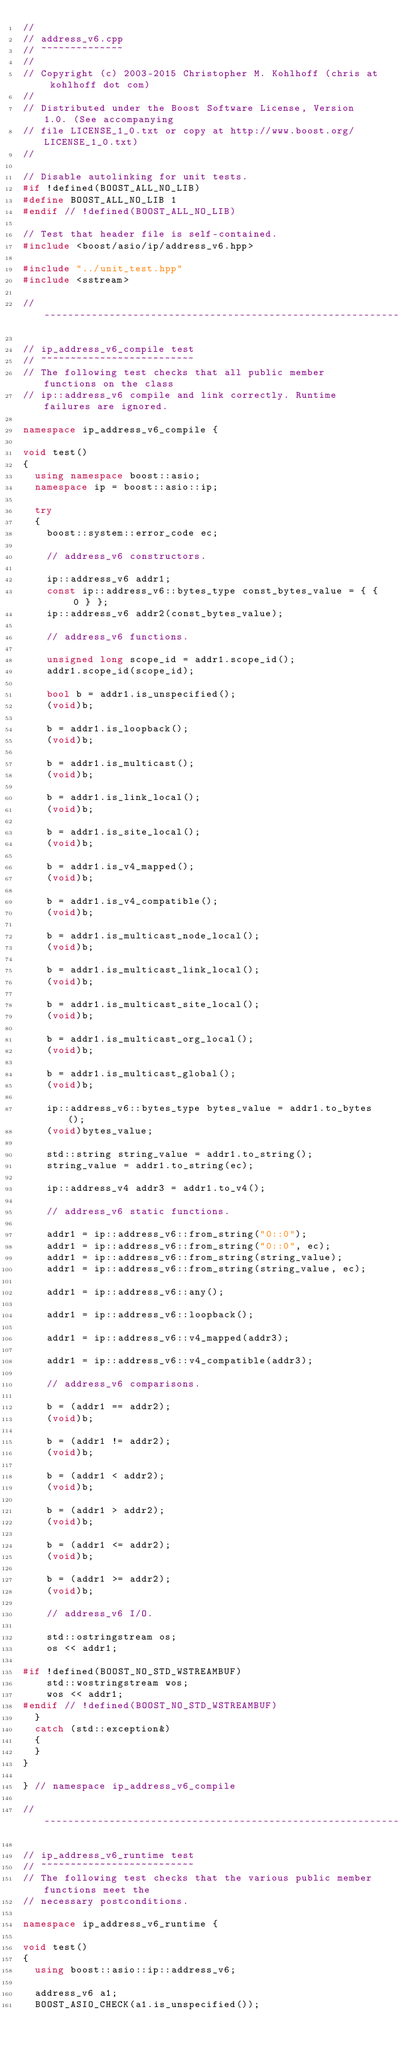Convert code to text. <code><loc_0><loc_0><loc_500><loc_500><_C++_>//
// address_v6.cpp
// ~~~~~~~~~~~~~~
//
// Copyright (c) 2003-2015 Christopher M. Kohlhoff (chris at kohlhoff dot com)
//
// Distributed under the Boost Software License, Version 1.0. (See accompanying
// file LICENSE_1_0.txt or copy at http://www.boost.org/LICENSE_1_0.txt)
//

// Disable autolinking for unit tests.
#if !defined(BOOST_ALL_NO_LIB)
#define BOOST_ALL_NO_LIB 1
#endif // !defined(BOOST_ALL_NO_LIB)

// Test that header file is self-contained.
#include <boost/asio/ip/address_v6.hpp>

#include "../unit_test.hpp"
#include <sstream>

//------------------------------------------------------------------------------

// ip_address_v6_compile test
// ~~~~~~~~~~~~~~~~~~~~~~~~~~
// The following test checks that all public member functions on the class
// ip::address_v6 compile and link correctly. Runtime failures are ignored.

namespace ip_address_v6_compile {

void test()
{
  using namespace boost::asio;
  namespace ip = boost::asio::ip;

  try
  {
    boost::system::error_code ec;

    // address_v6 constructors.

    ip::address_v6 addr1;
    const ip::address_v6::bytes_type const_bytes_value = { { 0 } };
    ip::address_v6 addr2(const_bytes_value);

    // address_v6 functions.

    unsigned long scope_id = addr1.scope_id();
    addr1.scope_id(scope_id);

    bool b = addr1.is_unspecified();
    (void)b;

    b = addr1.is_loopback();
    (void)b;

    b = addr1.is_multicast();
    (void)b;

    b = addr1.is_link_local();
    (void)b;

    b = addr1.is_site_local();
    (void)b;

    b = addr1.is_v4_mapped();
    (void)b;

    b = addr1.is_v4_compatible();
    (void)b;

    b = addr1.is_multicast_node_local();
    (void)b;

    b = addr1.is_multicast_link_local();
    (void)b;

    b = addr1.is_multicast_site_local();
    (void)b;

    b = addr1.is_multicast_org_local();
    (void)b;

    b = addr1.is_multicast_global();
    (void)b;

    ip::address_v6::bytes_type bytes_value = addr1.to_bytes();
    (void)bytes_value;

    std::string string_value = addr1.to_string();
    string_value = addr1.to_string(ec);

    ip::address_v4 addr3 = addr1.to_v4();

    // address_v6 static functions.

    addr1 = ip::address_v6::from_string("0::0");
    addr1 = ip::address_v6::from_string("0::0", ec);
    addr1 = ip::address_v6::from_string(string_value);
    addr1 = ip::address_v6::from_string(string_value, ec);

    addr1 = ip::address_v6::any();

    addr1 = ip::address_v6::loopback();

    addr1 = ip::address_v6::v4_mapped(addr3);

    addr1 = ip::address_v6::v4_compatible(addr3);

    // address_v6 comparisons.

    b = (addr1 == addr2);
    (void)b;

    b = (addr1 != addr2);
    (void)b;

    b = (addr1 < addr2);
    (void)b;

    b = (addr1 > addr2);
    (void)b;

    b = (addr1 <= addr2);
    (void)b;

    b = (addr1 >= addr2);
    (void)b;

    // address_v6 I/O.

    std::ostringstream os;
    os << addr1;

#if !defined(BOOST_NO_STD_WSTREAMBUF)
    std::wostringstream wos;
    wos << addr1;
#endif // !defined(BOOST_NO_STD_WSTREAMBUF)
  }
  catch (std::exception&)
  {
  }
}

} // namespace ip_address_v6_compile

//------------------------------------------------------------------------------

// ip_address_v6_runtime test
// ~~~~~~~~~~~~~~~~~~~~~~~~~~
// The following test checks that the various public member functions meet the
// necessary postconditions.

namespace ip_address_v6_runtime {

void test()
{
  using boost::asio::ip::address_v6;

  address_v6 a1;
  BOOST_ASIO_CHECK(a1.is_unspecified());</code> 